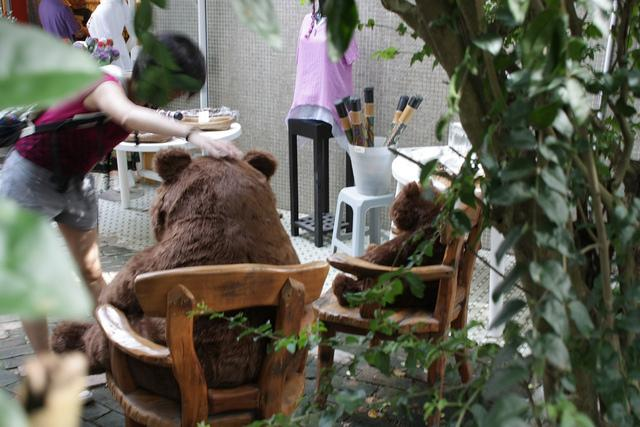How many bears are there? two 